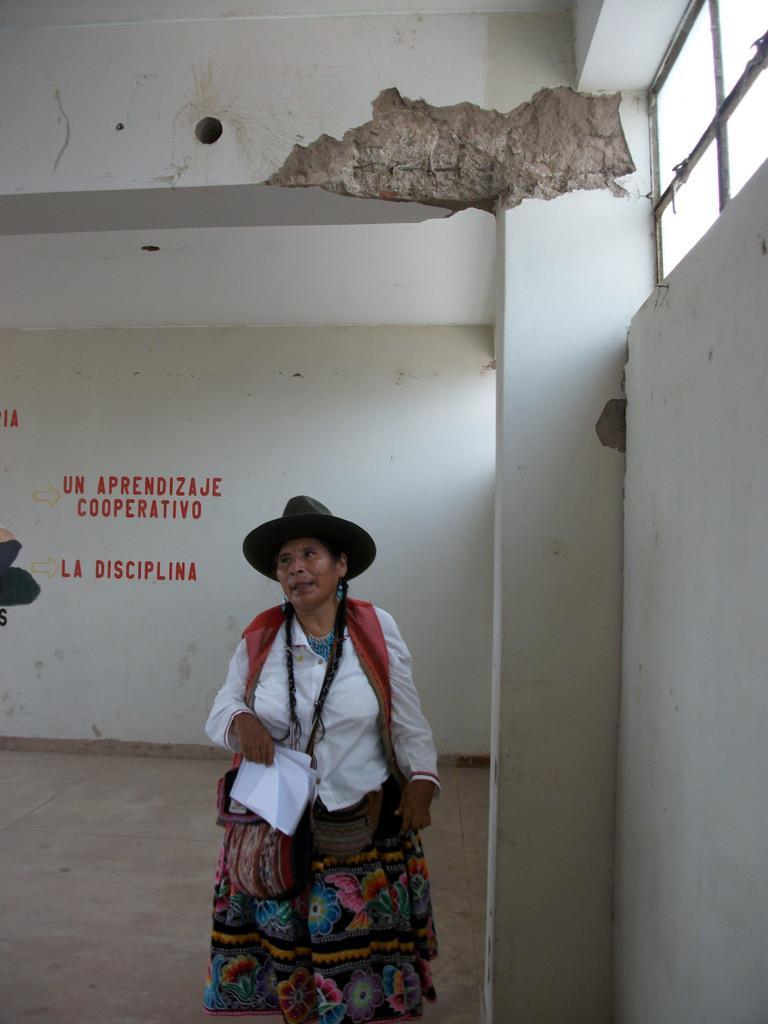How would you summarize this image in a sentence or two? In this image we can see a woman wearing costume, hat and bags is holding a book in her hands and standing on the floor. Here we can see the ventilator and some text on the wall. 